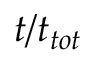Convert formula to latex. <formula><loc_0><loc_0><loc_500><loc_500>t / t _ { t o t }</formula> 